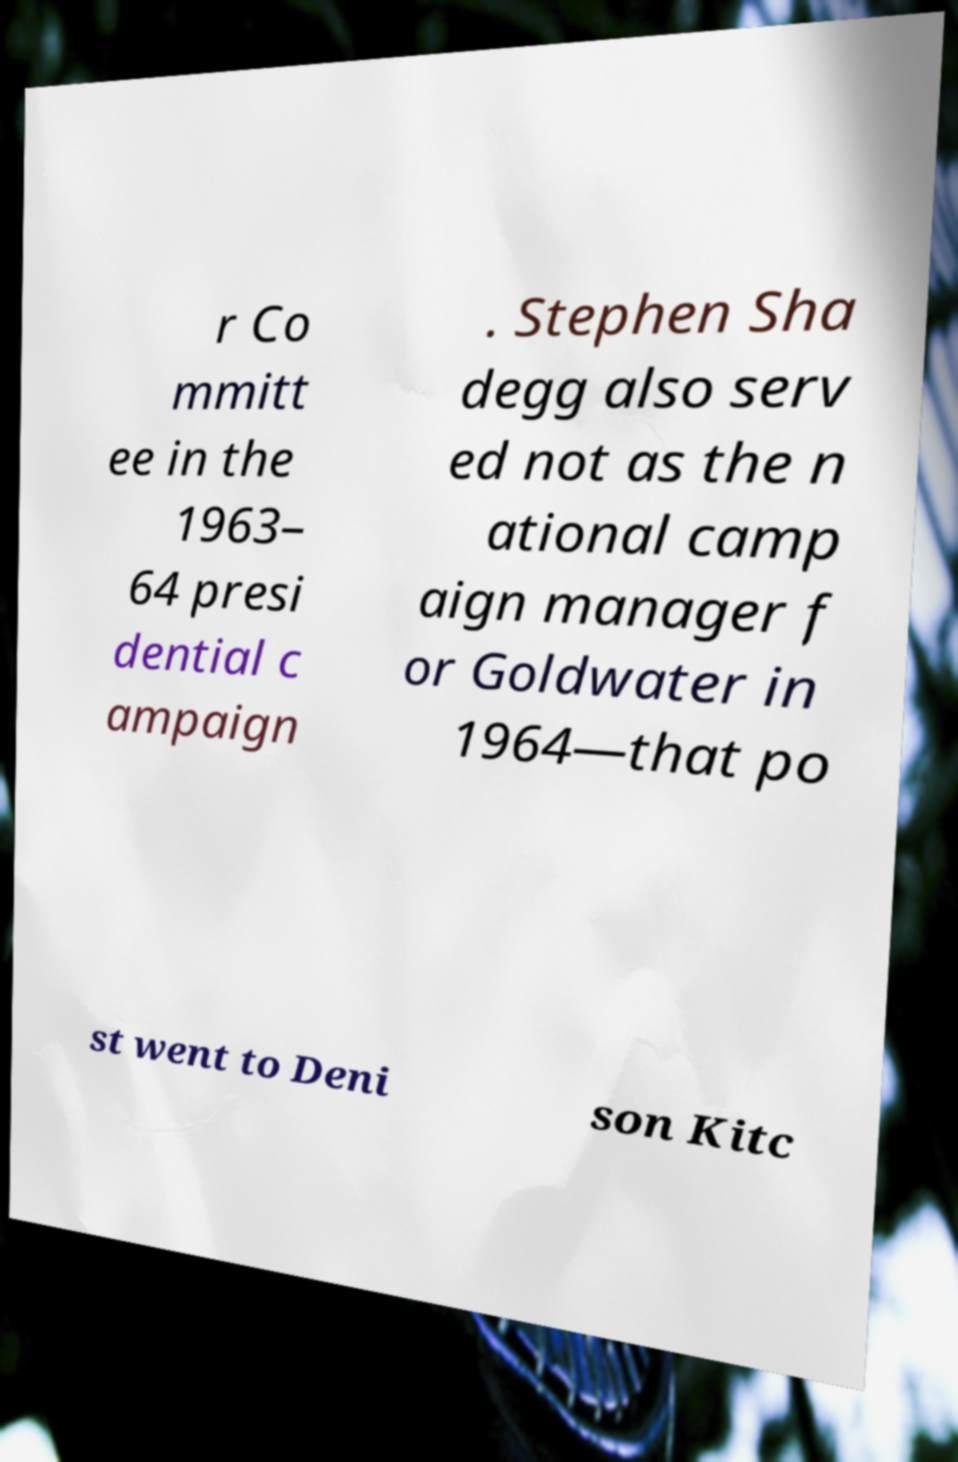What messages or text are displayed in this image? I need them in a readable, typed format. r Co mmitt ee in the 1963– 64 presi dential c ampaign . Stephen Sha degg also serv ed not as the n ational camp aign manager f or Goldwater in 1964—that po st went to Deni son Kitc 